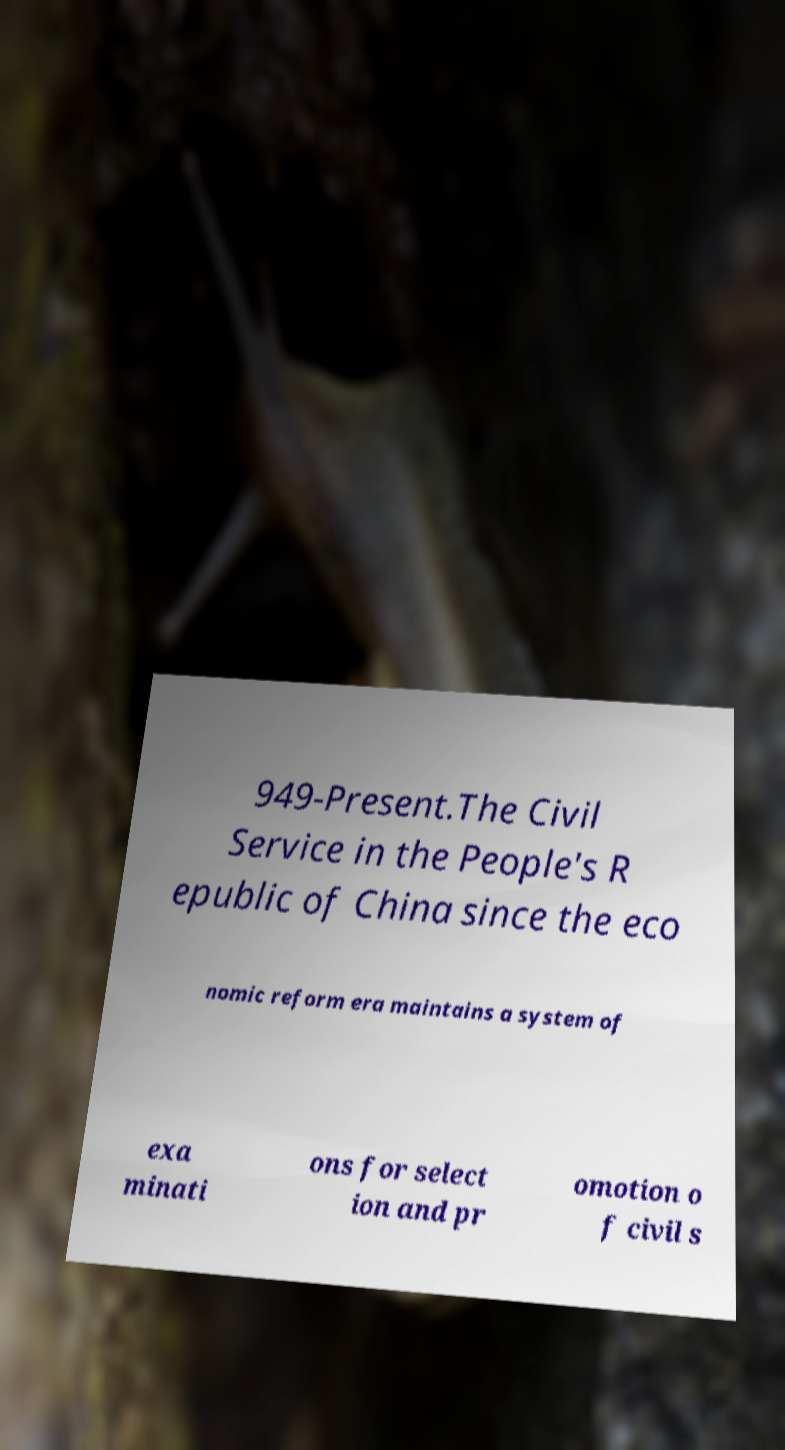Could you assist in decoding the text presented in this image and type it out clearly? 949-Present.The Civil Service in the People's R epublic of China since the eco nomic reform era maintains a system of exa minati ons for select ion and pr omotion o f civil s 